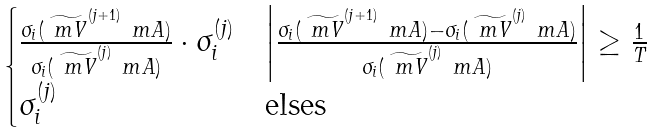Convert formula to latex. <formula><loc_0><loc_0><loc_500><loc_500>\begin{cases} \frac { \sigma _ { i } ( \widetilde { \ m V } ^ { ( j + 1 ) } \ m A ) } { \sigma _ { i } ( \widetilde { \ m V } ^ { ( j ) } \ m A ) } \cdot \sigma _ { i } ^ { ( j ) } & \left | \frac { \sigma _ { i } ( \widetilde { \ m V } ^ { ( j + 1 ) } \ m A ) - \sigma _ { i } ( \widetilde { \ m V } ^ { ( j ) } \ m A ) } { \sigma _ { i } ( \widetilde { \ m V } ^ { ( j ) } \ m A ) } \right | \geq \frac { 1 } { T } \\ \sigma _ { i } ^ { ( j ) } & \text {elses} \end{cases}</formula> 